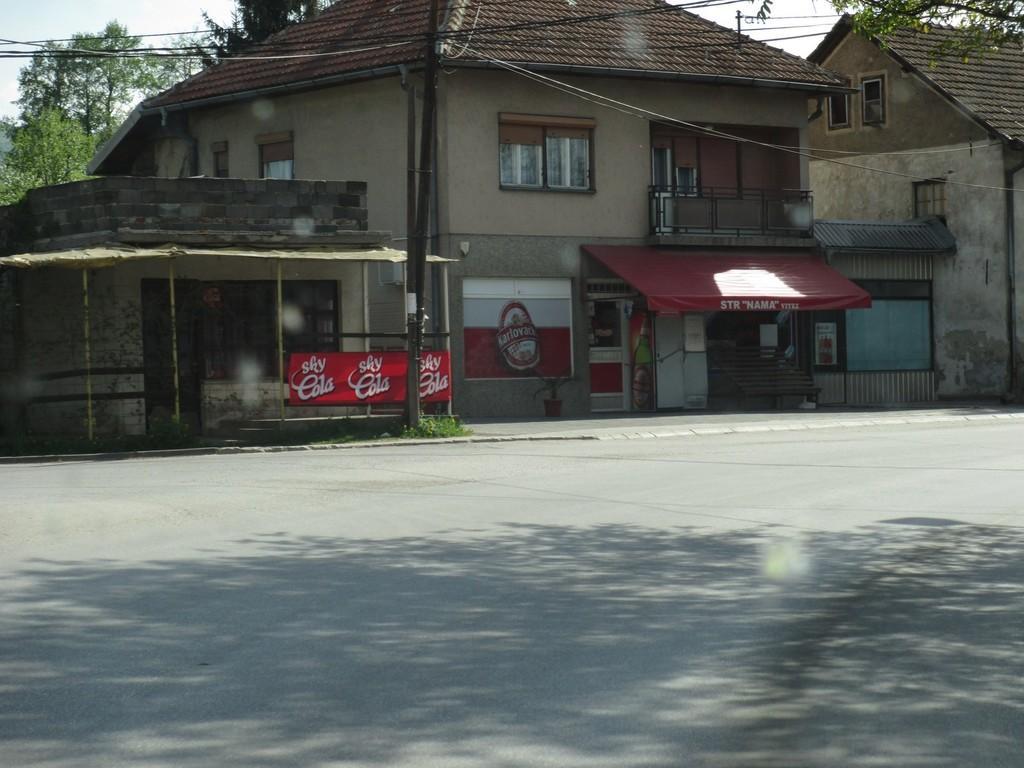Can you describe this image briefly? In the image there is a house and there is a store below the house, around that house there are few trees, wires and the road in front of the house is empty. 